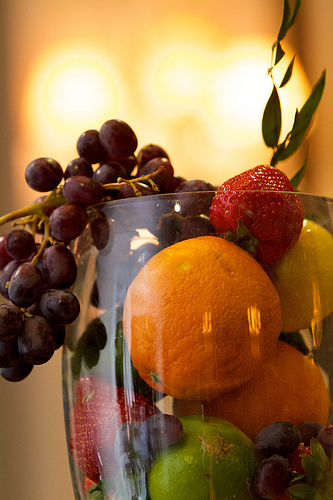<image>
Is there a orange to the right of the grapes? Yes. From this viewpoint, the orange is positioned to the right side relative to the grapes. 